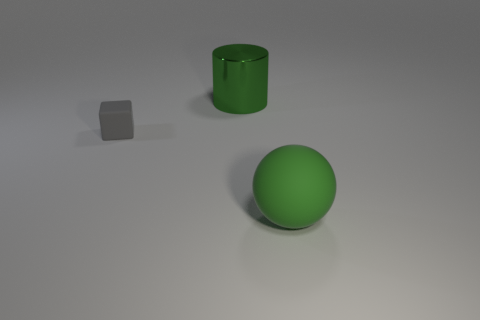There is a matte object behind the big green thing in front of the shiny cylinder; what number of rubber blocks are behind it?
Provide a succinct answer. 0. Are there the same number of tiny objects on the right side of the big green matte ball and big green objects?
Offer a very short reply. No. How many cubes are large blue shiny objects or big rubber things?
Keep it short and to the point. 0. Is the large shiny object the same color as the cube?
Ensure brevity in your answer.  No. Are there an equal number of shiny things behind the big shiny thing and green shiny cylinders that are to the left of the green rubber ball?
Make the answer very short. No. What is the color of the shiny cylinder?
Keep it short and to the point. Green. How many things are either matte objects that are right of the tiny gray matte thing or tiny brown metal objects?
Offer a very short reply. 1. Does the thing in front of the small gray matte object have the same size as the matte object behind the green ball?
Your response must be concise. No. Are there any other things that have the same material as the cylinder?
Provide a short and direct response. No. What number of objects are either green objects that are to the left of the large matte ball or rubber things behind the ball?
Make the answer very short. 2. 